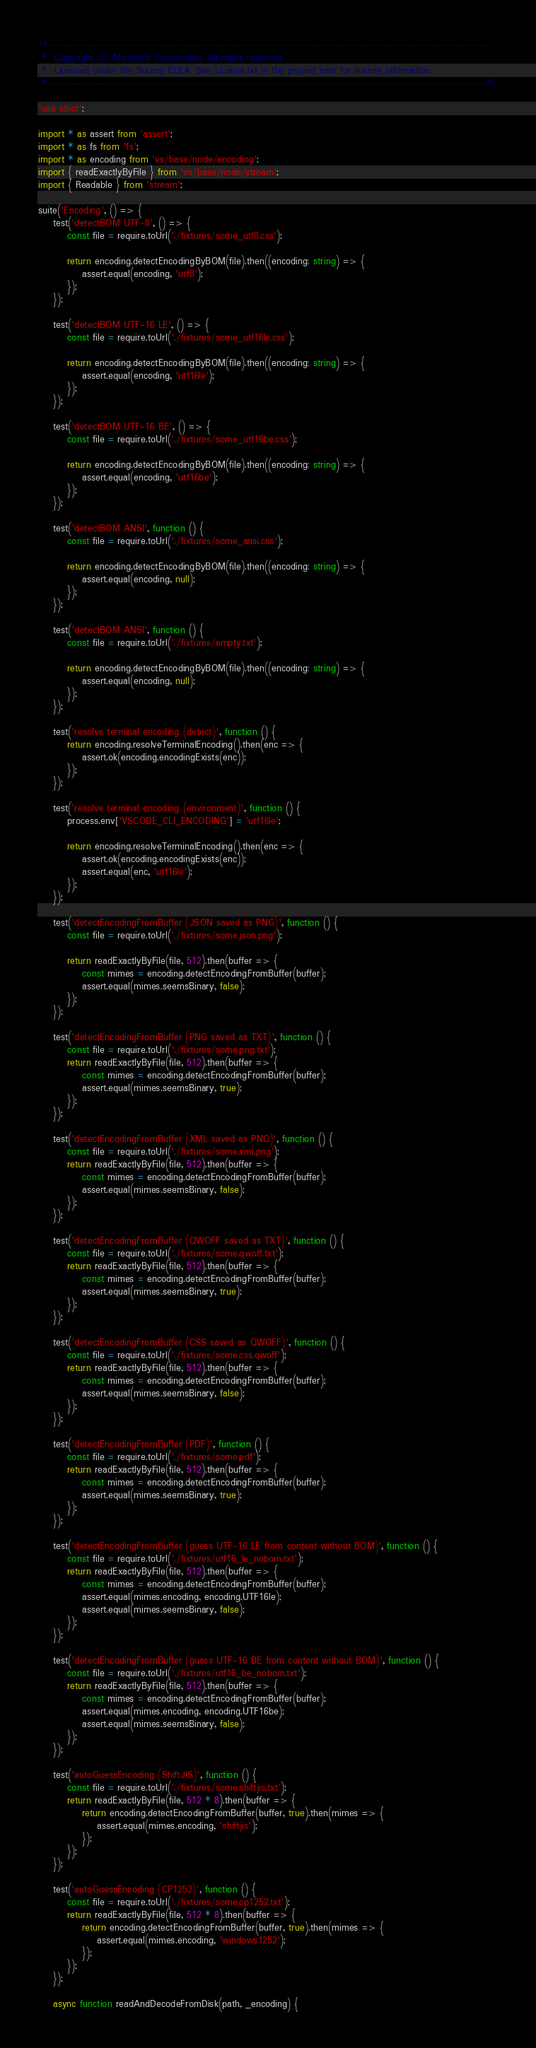<code> <loc_0><loc_0><loc_500><loc_500><_TypeScript_>/*---------------------------------------------------------------------------------------------
 *  Copyright (c) Microsoft Corporation. All rights reserved.
 *  Licensed under the Source EULA. See License.txt in the project root for license information.
 *--------------------------------------------------------------------------------------------*/

'use strict';

import * as assert from 'assert';
import * as fs from 'fs';
import * as encoding from 'vs/base/node/encoding';
import { readExactlyByFile } from 'vs/base/node/stream';
import { Readable } from 'stream';

suite('Encoding', () => {
	test('detectBOM UTF-8', () => {
		const file = require.toUrl('./fixtures/some_utf8.css');

		return encoding.detectEncodingByBOM(file).then((encoding: string) => {
			assert.equal(encoding, 'utf8');
		});
	});

	test('detectBOM UTF-16 LE', () => {
		const file = require.toUrl('./fixtures/some_utf16le.css');

		return encoding.detectEncodingByBOM(file).then((encoding: string) => {
			assert.equal(encoding, 'utf16le');
		});
	});

	test('detectBOM UTF-16 BE', () => {
		const file = require.toUrl('./fixtures/some_utf16be.css');

		return encoding.detectEncodingByBOM(file).then((encoding: string) => {
			assert.equal(encoding, 'utf16be');
		});
	});

	test('detectBOM ANSI', function () {
		const file = require.toUrl('./fixtures/some_ansi.css');

		return encoding.detectEncodingByBOM(file).then((encoding: string) => {
			assert.equal(encoding, null);
		});
	});

	test('detectBOM ANSI', function () {
		const file = require.toUrl('./fixtures/empty.txt');

		return encoding.detectEncodingByBOM(file).then((encoding: string) => {
			assert.equal(encoding, null);
		});
	});

	test('resolve terminal encoding (detect)', function () {
		return encoding.resolveTerminalEncoding().then(enc => {
			assert.ok(encoding.encodingExists(enc));
		});
	});

	test('resolve terminal encoding (environment)', function () {
		process.env['VSCODE_CLI_ENCODING'] = 'utf16le';

		return encoding.resolveTerminalEncoding().then(enc => {
			assert.ok(encoding.encodingExists(enc));
			assert.equal(enc, 'utf16le');
		});
	});

	test('detectEncodingFromBuffer (JSON saved as PNG)', function () {
		const file = require.toUrl('./fixtures/some.json.png');

		return readExactlyByFile(file, 512).then(buffer => {
			const mimes = encoding.detectEncodingFromBuffer(buffer);
			assert.equal(mimes.seemsBinary, false);
		});
	});

	test('detectEncodingFromBuffer (PNG saved as TXT)', function () {
		const file = require.toUrl('./fixtures/some.png.txt');
		return readExactlyByFile(file, 512).then(buffer => {
			const mimes = encoding.detectEncodingFromBuffer(buffer);
			assert.equal(mimes.seemsBinary, true);
		});
	});

	test('detectEncodingFromBuffer (XML saved as PNG)', function () {
		const file = require.toUrl('./fixtures/some.xml.png');
		return readExactlyByFile(file, 512).then(buffer => {
			const mimes = encoding.detectEncodingFromBuffer(buffer);
			assert.equal(mimes.seemsBinary, false);
		});
	});

	test('detectEncodingFromBuffer (QWOFF saved as TXT)', function () {
		const file = require.toUrl('./fixtures/some.qwoff.txt');
		return readExactlyByFile(file, 512).then(buffer => {
			const mimes = encoding.detectEncodingFromBuffer(buffer);
			assert.equal(mimes.seemsBinary, true);
		});
	});

	test('detectEncodingFromBuffer (CSS saved as QWOFF)', function () {
		const file = require.toUrl('./fixtures/some.css.qwoff');
		return readExactlyByFile(file, 512).then(buffer => {
			const mimes = encoding.detectEncodingFromBuffer(buffer);
			assert.equal(mimes.seemsBinary, false);
		});
	});

	test('detectEncodingFromBuffer (PDF)', function () {
		const file = require.toUrl('./fixtures/some.pdf');
		return readExactlyByFile(file, 512).then(buffer => {
			const mimes = encoding.detectEncodingFromBuffer(buffer);
			assert.equal(mimes.seemsBinary, true);
		});
	});

	test('detectEncodingFromBuffer (guess UTF-16 LE from content without BOM)', function () {
		const file = require.toUrl('./fixtures/utf16_le_nobom.txt');
		return readExactlyByFile(file, 512).then(buffer => {
			const mimes = encoding.detectEncodingFromBuffer(buffer);
			assert.equal(mimes.encoding, encoding.UTF16le);
			assert.equal(mimes.seemsBinary, false);
		});
	});

	test('detectEncodingFromBuffer (guess UTF-16 BE from content without BOM)', function () {
		const file = require.toUrl('./fixtures/utf16_be_nobom.txt');
		return readExactlyByFile(file, 512).then(buffer => {
			const mimes = encoding.detectEncodingFromBuffer(buffer);
			assert.equal(mimes.encoding, encoding.UTF16be);
			assert.equal(mimes.seemsBinary, false);
		});
	});

	test('autoGuessEncoding (ShiftJIS)', function () {
		const file = require.toUrl('./fixtures/some.shiftjis.txt');
		return readExactlyByFile(file, 512 * 8).then(buffer => {
			return encoding.detectEncodingFromBuffer(buffer, true).then(mimes => {
				assert.equal(mimes.encoding, 'shiftjis');
			});
		});
	});

	test('autoGuessEncoding (CP1252)', function () {
		const file = require.toUrl('./fixtures/some.cp1252.txt');
		return readExactlyByFile(file, 512 * 8).then(buffer => {
			return encoding.detectEncodingFromBuffer(buffer, true).then(mimes => {
				assert.equal(mimes.encoding, 'windows1252');
			});
		});
	});

	async function readAndDecodeFromDisk(path, _encoding) {</code> 